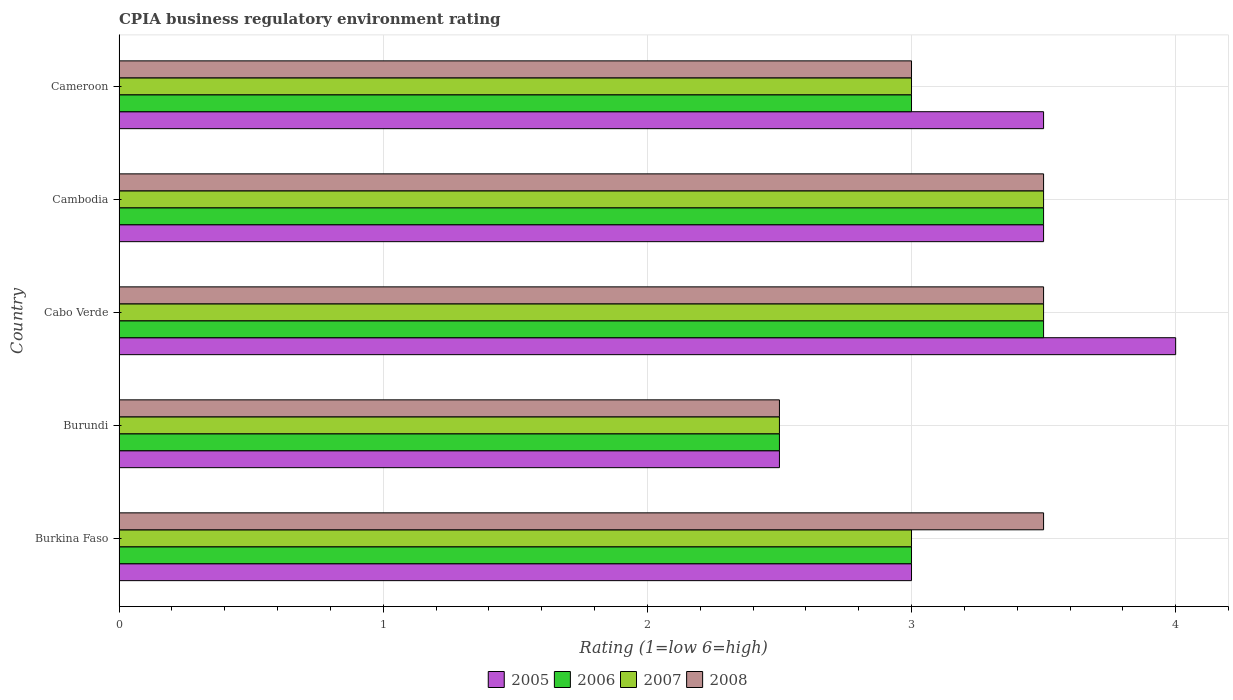How many different coloured bars are there?
Make the answer very short. 4. How many groups of bars are there?
Provide a succinct answer. 5. Are the number of bars per tick equal to the number of legend labels?
Provide a short and direct response. Yes. Are the number of bars on each tick of the Y-axis equal?
Provide a short and direct response. Yes. How many bars are there on the 4th tick from the top?
Offer a terse response. 4. What is the label of the 1st group of bars from the top?
Offer a very short reply. Cameroon. In how many cases, is the number of bars for a given country not equal to the number of legend labels?
Your answer should be very brief. 0. What is the CPIA rating in 2007 in Cameroon?
Your response must be concise. 3. In which country was the CPIA rating in 2008 maximum?
Provide a succinct answer. Burkina Faso. In which country was the CPIA rating in 2005 minimum?
Keep it short and to the point. Burundi. What is the difference between the CPIA rating in 2006 in Burundi and the CPIA rating in 2005 in Cabo Verde?
Ensure brevity in your answer.  -1.5. What is the average CPIA rating in 2005 per country?
Provide a succinct answer. 3.3. What is the difference between the CPIA rating in 2005 and CPIA rating in 2008 in Cameroon?
Keep it short and to the point. 0.5. In how many countries, is the CPIA rating in 2005 greater than 2 ?
Your answer should be compact. 5. What is the ratio of the CPIA rating in 2006 in Cambodia to that in Cameroon?
Ensure brevity in your answer.  1.17. Is the CPIA rating in 2007 in Burkina Faso less than that in Cameroon?
Make the answer very short. No. What is the difference between the highest and the lowest CPIA rating in 2008?
Your response must be concise. 1. Is the sum of the CPIA rating in 2005 in Cabo Verde and Cambodia greater than the maximum CPIA rating in 2006 across all countries?
Provide a succinct answer. Yes. Is it the case that in every country, the sum of the CPIA rating in 2005 and CPIA rating in 2006 is greater than the sum of CPIA rating in 2007 and CPIA rating in 2008?
Provide a succinct answer. No. Is it the case that in every country, the sum of the CPIA rating in 2007 and CPIA rating in 2006 is greater than the CPIA rating in 2008?
Give a very brief answer. Yes. How many bars are there?
Provide a succinct answer. 20. Are all the bars in the graph horizontal?
Your answer should be compact. Yes. How many countries are there in the graph?
Your response must be concise. 5. What is the difference between two consecutive major ticks on the X-axis?
Your answer should be compact. 1. Where does the legend appear in the graph?
Provide a short and direct response. Bottom center. How are the legend labels stacked?
Offer a very short reply. Horizontal. What is the title of the graph?
Your response must be concise. CPIA business regulatory environment rating. What is the Rating (1=low 6=high) of 2005 in Burkina Faso?
Provide a succinct answer. 3. What is the Rating (1=low 6=high) of 2006 in Burkina Faso?
Provide a short and direct response. 3. What is the Rating (1=low 6=high) of 2005 in Burundi?
Make the answer very short. 2.5. What is the Rating (1=low 6=high) in 2007 in Burundi?
Provide a succinct answer. 2.5. What is the Rating (1=low 6=high) of 2008 in Burundi?
Give a very brief answer. 2.5. What is the Rating (1=low 6=high) in 2005 in Cabo Verde?
Offer a terse response. 4. What is the Rating (1=low 6=high) in 2008 in Cabo Verde?
Provide a short and direct response. 3.5. What is the Rating (1=low 6=high) of 2005 in Cambodia?
Make the answer very short. 3.5. What is the Rating (1=low 6=high) in 2006 in Cambodia?
Provide a succinct answer. 3.5. What is the Rating (1=low 6=high) of 2007 in Cambodia?
Your answer should be compact. 3.5. What is the Rating (1=low 6=high) in 2007 in Cameroon?
Give a very brief answer. 3. What is the Rating (1=low 6=high) in 2008 in Cameroon?
Your answer should be very brief. 3. Across all countries, what is the maximum Rating (1=low 6=high) of 2005?
Ensure brevity in your answer.  4. Across all countries, what is the maximum Rating (1=low 6=high) in 2007?
Ensure brevity in your answer.  3.5. Across all countries, what is the maximum Rating (1=low 6=high) in 2008?
Your answer should be very brief. 3.5. Across all countries, what is the minimum Rating (1=low 6=high) of 2005?
Ensure brevity in your answer.  2.5. Across all countries, what is the minimum Rating (1=low 6=high) of 2006?
Offer a terse response. 2.5. What is the total Rating (1=low 6=high) of 2006 in the graph?
Keep it short and to the point. 15.5. What is the total Rating (1=low 6=high) of 2007 in the graph?
Keep it short and to the point. 15.5. What is the difference between the Rating (1=low 6=high) in 2006 in Burkina Faso and that in Burundi?
Make the answer very short. 0.5. What is the difference between the Rating (1=low 6=high) of 2006 in Burkina Faso and that in Cabo Verde?
Your response must be concise. -0.5. What is the difference between the Rating (1=low 6=high) in 2008 in Burkina Faso and that in Cabo Verde?
Provide a short and direct response. 0. What is the difference between the Rating (1=low 6=high) of 2006 in Burkina Faso and that in Cambodia?
Offer a very short reply. -0.5. What is the difference between the Rating (1=low 6=high) in 2007 in Burkina Faso and that in Cambodia?
Ensure brevity in your answer.  -0.5. What is the difference between the Rating (1=low 6=high) of 2005 in Burkina Faso and that in Cameroon?
Provide a succinct answer. -0.5. What is the difference between the Rating (1=low 6=high) in 2006 in Burkina Faso and that in Cameroon?
Your response must be concise. 0. What is the difference between the Rating (1=low 6=high) of 2007 in Burundi and that in Cabo Verde?
Give a very brief answer. -1. What is the difference between the Rating (1=low 6=high) of 2008 in Burundi and that in Cabo Verde?
Provide a short and direct response. -1. What is the difference between the Rating (1=low 6=high) of 2006 in Burundi and that in Cambodia?
Ensure brevity in your answer.  -1. What is the difference between the Rating (1=low 6=high) in 2008 in Burundi and that in Cameroon?
Keep it short and to the point. -0.5. What is the difference between the Rating (1=low 6=high) in 2005 in Cabo Verde and that in Cambodia?
Provide a short and direct response. 0.5. What is the difference between the Rating (1=low 6=high) of 2006 in Cabo Verde and that in Cambodia?
Make the answer very short. 0. What is the difference between the Rating (1=low 6=high) in 2008 in Cabo Verde and that in Cambodia?
Make the answer very short. 0. What is the difference between the Rating (1=low 6=high) of 2005 in Cabo Verde and that in Cameroon?
Provide a short and direct response. 0.5. What is the difference between the Rating (1=low 6=high) in 2007 in Cabo Verde and that in Cameroon?
Ensure brevity in your answer.  0.5. What is the difference between the Rating (1=low 6=high) of 2008 in Cabo Verde and that in Cameroon?
Ensure brevity in your answer.  0.5. What is the difference between the Rating (1=low 6=high) in 2005 in Cambodia and that in Cameroon?
Provide a short and direct response. 0. What is the difference between the Rating (1=low 6=high) in 2006 in Cambodia and that in Cameroon?
Your answer should be very brief. 0.5. What is the difference between the Rating (1=low 6=high) in 2007 in Cambodia and that in Cameroon?
Give a very brief answer. 0.5. What is the difference between the Rating (1=low 6=high) of 2008 in Cambodia and that in Cameroon?
Offer a terse response. 0.5. What is the difference between the Rating (1=low 6=high) in 2005 in Burkina Faso and the Rating (1=low 6=high) in 2006 in Burundi?
Give a very brief answer. 0.5. What is the difference between the Rating (1=low 6=high) of 2005 in Burkina Faso and the Rating (1=low 6=high) of 2008 in Burundi?
Offer a terse response. 0.5. What is the difference between the Rating (1=low 6=high) in 2006 in Burkina Faso and the Rating (1=low 6=high) in 2007 in Burundi?
Your answer should be compact. 0.5. What is the difference between the Rating (1=low 6=high) of 2006 in Burkina Faso and the Rating (1=low 6=high) of 2008 in Burundi?
Ensure brevity in your answer.  0.5. What is the difference between the Rating (1=low 6=high) in 2007 in Burkina Faso and the Rating (1=low 6=high) in 2008 in Burundi?
Your answer should be very brief. 0.5. What is the difference between the Rating (1=low 6=high) in 2005 in Burkina Faso and the Rating (1=low 6=high) in 2007 in Cabo Verde?
Make the answer very short. -0.5. What is the difference between the Rating (1=low 6=high) of 2005 in Burkina Faso and the Rating (1=low 6=high) of 2008 in Cabo Verde?
Your response must be concise. -0.5. What is the difference between the Rating (1=low 6=high) of 2006 in Burkina Faso and the Rating (1=low 6=high) of 2007 in Cabo Verde?
Provide a succinct answer. -0.5. What is the difference between the Rating (1=low 6=high) of 2007 in Burkina Faso and the Rating (1=low 6=high) of 2008 in Cabo Verde?
Keep it short and to the point. -0.5. What is the difference between the Rating (1=low 6=high) of 2005 in Burkina Faso and the Rating (1=low 6=high) of 2006 in Cambodia?
Make the answer very short. -0.5. What is the difference between the Rating (1=low 6=high) of 2006 in Burkina Faso and the Rating (1=low 6=high) of 2007 in Cambodia?
Your answer should be compact. -0.5. What is the difference between the Rating (1=low 6=high) of 2005 in Burkina Faso and the Rating (1=low 6=high) of 2006 in Cameroon?
Provide a succinct answer. 0. What is the difference between the Rating (1=low 6=high) in 2006 in Burkina Faso and the Rating (1=low 6=high) in 2008 in Cameroon?
Offer a very short reply. 0. What is the difference between the Rating (1=low 6=high) of 2007 in Burkina Faso and the Rating (1=low 6=high) of 2008 in Cameroon?
Provide a short and direct response. 0. What is the difference between the Rating (1=low 6=high) of 2005 in Burundi and the Rating (1=low 6=high) of 2006 in Cabo Verde?
Provide a succinct answer. -1. What is the difference between the Rating (1=low 6=high) in 2005 in Burundi and the Rating (1=low 6=high) in 2007 in Cabo Verde?
Your answer should be compact. -1. What is the difference between the Rating (1=low 6=high) of 2005 in Burundi and the Rating (1=low 6=high) of 2008 in Cabo Verde?
Make the answer very short. -1. What is the difference between the Rating (1=low 6=high) in 2006 in Burundi and the Rating (1=low 6=high) in 2007 in Cabo Verde?
Offer a terse response. -1. What is the difference between the Rating (1=low 6=high) in 2007 in Burundi and the Rating (1=low 6=high) in 2008 in Cabo Verde?
Your answer should be compact. -1. What is the difference between the Rating (1=low 6=high) in 2005 in Burundi and the Rating (1=low 6=high) in 2007 in Cambodia?
Your response must be concise. -1. What is the difference between the Rating (1=low 6=high) of 2005 in Burundi and the Rating (1=low 6=high) of 2008 in Cambodia?
Provide a short and direct response. -1. What is the difference between the Rating (1=low 6=high) of 2005 in Burundi and the Rating (1=low 6=high) of 2006 in Cameroon?
Provide a succinct answer. -0.5. What is the difference between the Rating (1=low 6=high) in 2005 in Burundi and the Rating (1=low 6=high) in 2007 in Cameroon?
Keep it short and to the point. -0.5. What is the difference between the Rating (1=low 6=high) in 2005 in Burundi and the Rating (1=low 6=high) in 2008 in Cameroon?
Give a very brief answer. -0.5. What is the difference between the Rating (1=low 6=high) of 2006 in Burundi and the Rating (1=low 6=high) of 2007 in Cameroon?
Provide a succinct answer. -0.5. What is the difference between the Rating (1=low 6=high) in 2006 in Burundi and the Rating (1=low 6=high) in 2008 in Cameroon?
Ensure brevity in your answer.  -0.5. What is the difference between the Rating (1=low 6=high) in 2006 in Cabo Verde and the Rating (1=low 6=high) in 2007 in Cambodia?
Make the answer very short. 0. What is the difference between the Rating (1=low 6=high) of 2006 in Cabo Verde and the Rating (1=low 6=high) of 2008 in Cambodia?
Your answer should be compact. 0. What is the difference between the Rating (1=low 6=high) in 2005 in Cabo Verde and the Rating (1=low 6=high) in 2007 in Cameroon?
Your answer should be very brief. 1. What is the difference between the Rating (1=low 6=high) of 2005 in Cabo Verde and the Rating (1=low 6=high) of 2008 in Cameroon?
Make the answer very short. 1. What is the difference between the Rating (1=low 6=high) of 2006 in Cabo Verde and the Rating (1=low 6=high) of 2008 in Cameroon?
Provide a succinct answer. 0.5. What is the difference between the Rating (1=low 6=high) of 2005 in Cambodia and the Rating (1=low 6=high) of 2006 in Cameroon?
Your answer should be compact. 0.5. What is the difference between the Rating (1=low 6=high) of 2005 in Cambodia and the Rating (1=low 6=high) of 2007 in Cameroon?
Your answer should be very brief. 0.5. What is the difference between the Rating (1=low 6=high) in 2007 in Cambodia and the Rating (1=low 6=high) in 2008 in Cameroon?
Offer a very short reply. 0.5. What is the average Rating (1=low 6=high) of 2006 per country?
Your response must be concise. 3.1. What is the average Rating (1=low 6=high) of 2007 per country?
Ensure brevity in your answer.  3.1. What is the difference between the Rating (1=low 6=high) in 2005 and Rating (1=low 6=high) in 2007 in Burkina Faso?
Provide a short and direct response. 0. What is the difference between the Rating (1=low 6=high) of 2005 and Rating (1=low 6=high) of 2008 in Burkina Faso?
Give a very brief answer. -0.5. What is the difference between the Rating (1=low 6=high) in 2005 and Rating (1=low 6=high) in 2008 in Burundi?
Give a very brief answer. 0. What is the difference between the Rating (1=low 6=high) of 2005 and Rating (1=low 6=high) of 2008 in Cabo Verde?
Your response must be concise. 0.5. What is the difference between the Rating (1=low 6=high) in 2006 and Rating (1=low 6=high) in 2007 in Cabo Verde?
Offer a terse response. 0. What is the difference between the Rating (1=low 6=high) in 2006 and Rating (1=low 6=high) in 2008 in Cabo Verde?
Make the answer very short. 0. What is the difference between the Rating (1=low 6=high) of 2005 and Rating (1=low 6=high) of 2006 in Cambodia?
Your response must be concise. 0. What is the difference between the Rating (1=low 6=high) of 2005 and Rating (1=low 6=high) of 2008 in Cambodia?
Make the answer very short. 0. What is the difference between the Rating (1=low 6=high) of 2006 and Rating (1=low 6=high) of 2007 in Cambodia?
Your answer should be compact. 0. What is the difference between the Rating (1=low 6=high) in 2006 and Rating (1=low 6=high) in 2008 in Cambodia?
Give a very brief answer. 0. What is the difference between the Rating (1=low 6=high) in 2007 and Rating (1=low 6=high) in 2008 in Cambodia?
Give a very brief answer. 0. What is the difference between the Rating (1=low 6=high) of 2005 and Rating (1=low 6=high) of 2006 in Cameroon?
Keep it short and to the point. 0.5. What is the difference between the Rating (1=low 6=high) in 2005 and Rating (1=low 6=high) in 2007 in Cameroon?
Your response must be concise. 0.5. What is the difference between the Rating (1=low 6=high) in 2005 and Rating (1=low 6=high) in 2008 in Cameroon?
Give a very brief answer. 0.5. What is the difference between the Rating (1=low 6=high) in 2007 and Rating (1=low 6=high) in 2008 in Cameroon?
Your response must be concise. 0. What is the ratio of the Rating (1=low 6=high) in 2008 in Burkina Faso to that in Burundi?
Offer a terse response. 1.4. What is the ratio of the Rating (1=low 6=high) in 2006 in Burkina Faso to that in Cabo Verde?
Offer a terse response. 0.86. What is the ratio of the Rating (1=low 6=high) in 2007 in Burkina Faso to that in Cabo Verde?
Ensure brevity in your answer.  0.86. What is the ratio of the Rating (1=low 6=high) in 2008 in Burkina Faso to that in Cabo Verde?
Offer a terse response. 1. What is the ratio of the Rating (1=low 6=high) of 2006 in Burkina Faso to that in Cambodia?
Provide a short and direct response. 0.86. What is the ratio of the Rating (1=low 6=high) in 2007 in Burkina Faso to that in Cambodia?
Your answer should be very brief. 0.86. What is the ratio of the Rating (1=low 6=high) in 2008 in Burkina Faso to that in Cambodia?
Offer a terse response. 1. What is the ratio of the Rating (1=low 6=high) in 2005 in Burundi to that in Cabo Verde?
Keep it short and to the point. 0.62. What is the ratio of the Rating (1=low 6=high) in 2006 in Burundi to that in Cabo Verde?
Offer a very short reply. 0.71. What is the ratio of the Rating (1=low 6=high) in 2008 in Burundi to that in Cabo Verde?
Provide a short and direct response. 0.71. What is the ratio of the Rating (1=low 6=high) in 2006 in Burundi to that in Cambodia?
Provide a succinct answer. 0.71. What is the ratio of the Rating (1=low 6=high) of 2007 in Burundi to that in Cambodia?
Your answer should be compact. 0.71. What is the ratio of the Rating (1=low 6=high) in 2008 in Burundi to that in Cambodia?
Your answer should be compact. 0.71. What is the ratio of the Rating (1=low 6=high) of 2007 in Burundi to that in Cameroon?
Make the answer very short. 0.83. What is the ratio of the Rating (1=low 6=high) in 2006 in Cabo Verde to that in Cambodia?
Provide a short and direct response. 1. What is the ratio of the Rating (1=low 6=high) of 2007 in Cabo Verde to that in Cambodia?
Offer a very short reply. 1. What is the ratio of the Rating (1=low 6=high) of 2005 in Cabo Verde to that in Cameroon?
Keep it short and to the point. 1.14. What is the ratio of the Rating (1=low 6=high) in 2006 in Cabo Verde to that in Cameroon?
Keep it short and to the point. 1.17. What is the ratio of the Rating (1=low 6=high) of 2007 in Cabo Verde to that in Cameroon?
Ensure brevity in your answer.  1.17. What is the ratio of the Rating (1=low 6=high) of 2005 in Cambodia to that in Cameroon?
Give a very brief answer. 1. What is the ratio of the Rating (1=low 6=high) in 2006 in Cambodia to that in Cameroon?
Ensure brevity in your answer.  1.17. What is the ratio of the Rating (1=low 6=high) in 2007 in Cambodia to that in Cameroon?
Ensure brevity in your answer.  1.17. What is the ratio of the Rating (1=low 6=high) of 2008 in Cambodia to that in Cameroon?
Ensure brevity in your answer.  1.17. What is the difference between the highest and the second highest Rating (1=low 6=high) in 2005?
Ensure brevity in your answer.  0.5. What is the difference between the highest and the second highest Rating (1=low 6=high) of 2008?
Make the answer very short. 0. What is the difference between the highest and the lowest Rating (1=low 6=high) of 2006?
Your response must be concise. 1. 